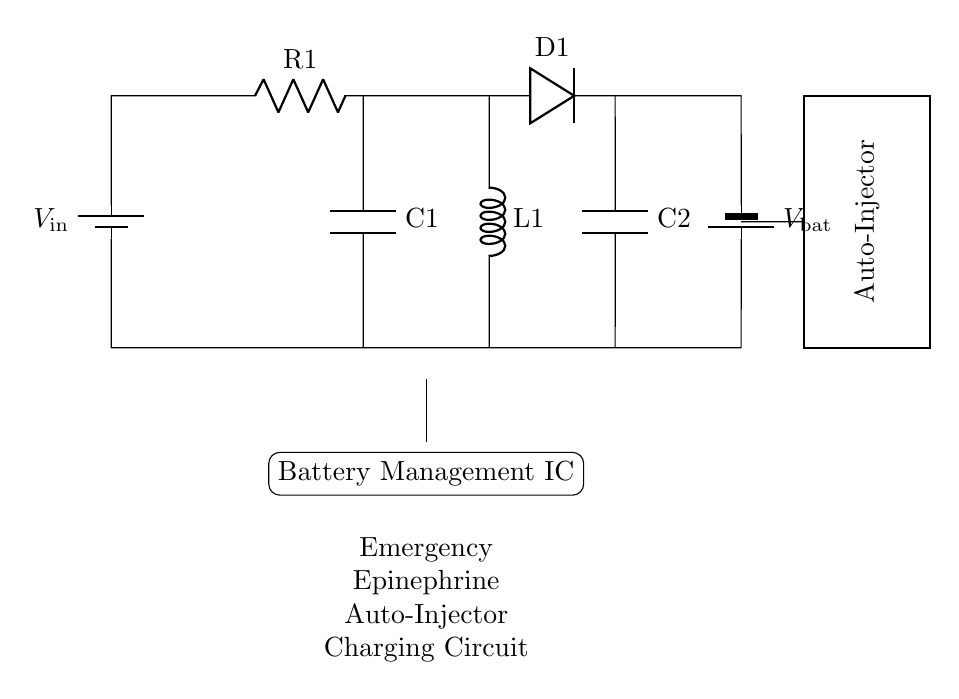What is the input voltage of the circuit? The input voltage is labeled as \( V_{\text{in}} \) on the circuit diagram, indicating it is the starting voltage supplied to the circuit.
Answer: \( V_{\text{in}} \) What component is used to store energy in this circuit? The capacitors labeled as \( C1 \) and \( C2 \) are used to store energy in the circuit, which is essential in managing the charge for the battery.
Answer: Capacitors Which component allows current to flow in only one direction? The diode labeled as \( D1 \) allows current to flow in only one direction, preventing backflow and protecting the circuit.
Answer: Diode How is the battery management IC depicted in the circuit? The battery management IC is represented as a rectangle with a label indicating its function, which manages the charging current and battery status.
Answer: Rectangle What is the role of \( R1 \) in this circuit? The resistor \( R1 \) limits the current flowing through the circuit to ensure safe charging of the batteries and prevent damage from excessive current.
Answer: Current limiter What happens if the capacitor \( C1 \) fails in this circuit? If capacitor \( C1 \) fails, it could lead to insufficient energy storage, affecting the circuit's ability to charge the battery properly and supply power to the auto-injector.
Answer: Insufficient charge What type of circuit is depicted in the diagram? This is a charging circuit designed specifically for an emergency epinephrine auto-injector, aimed at keeping the device powered when needed.
Answer: Charging circuit 